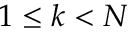<formula> <loc_0><loc_0><loc_500><loc_500>1 \leq k < N</formula> 